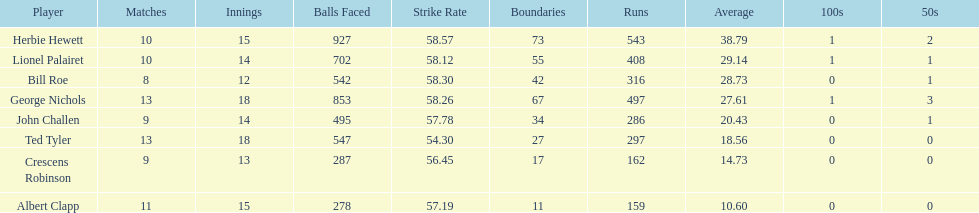Can you parse all the data within this table? {'header': ['Player', 'Matches', 'Innings', 'Balls Faced', 'Strike Rate', 'Boundaries', 'Runs', 'Average', '100s', '50s'], 'rows': [['Herbie Hewett', '10', '15', '927', '58.57', '73', '543', '38.79', '1', '2'], ['Lionel Palairet', '10', '14', '702', '58.12', '55', '408', '29.14', '1', '1'], ['Bill Roe', '8', '12', '542', '58.30', '42', '316', '28.73', '0', '1'], ['George Nichols', '13', '18', '853', '58.26', '67', '497', '27.61', '1', '3'], ['John Challen', '9', '14', '495', '57.78', '34', '286', '20.43', '0', '1'], ['Ted Tyler', '13', '18', '547', '54.30', '27', '297', '18.56', '0', '0'], ['Crescens Robinson', '9', '13', '287', '56.45', '17', '162', '14.73', '0', '0'], ['Albert Clapp', '11', '15', '278', '57.19', '11', '159', '10.60', '0', '0']]} Name a player whose average was above 25. Herbie Hewett. 